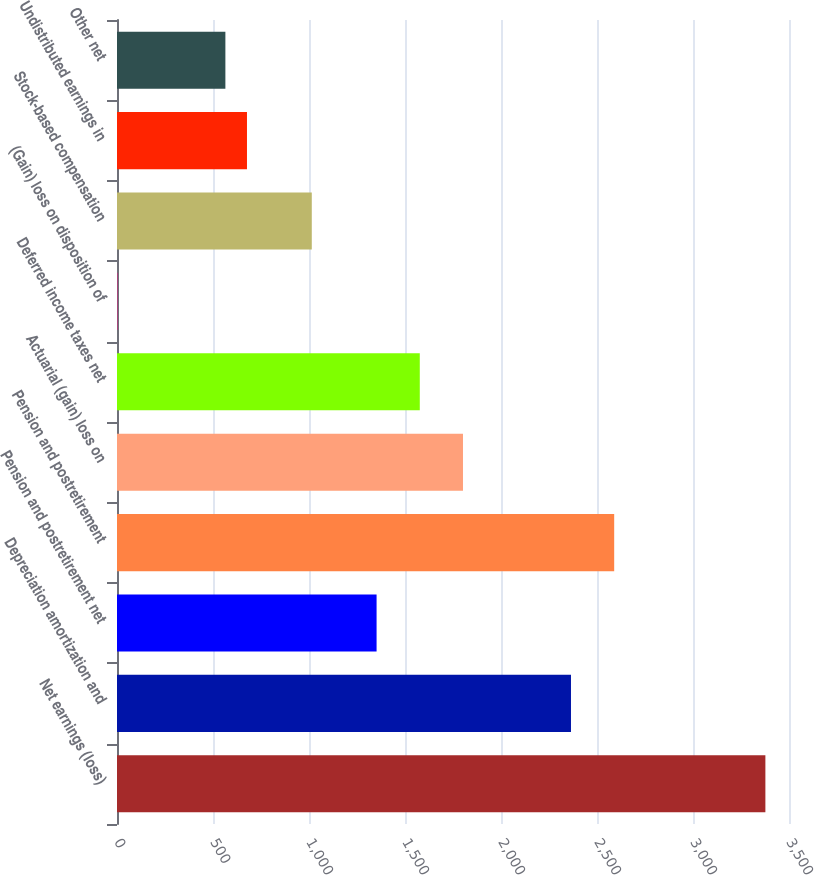Convert chart. <chart><loc_0><loc_0><loc_500><loc_500><bar_chart><fcel>Net earnings (loss)<fcel>Depreciation amortization and<fcel>Pension and postretirement net<fcel>Pension and postretirement<fcel>Actuarial (gain) loss on<fcel>Deferred income taxes net<fcel>(Gain) loss on disposition of<fcel>Stock-based compensation<fcel>Undistributed earnings in<fcel>Other net<nl><fcel>3377<fcel>2364.5<fcel>1352<fcel>2589.5<fcel>1802<fcel>1577<fcel>2<fcel>1014.5<fcel>677<fcel>564.5<nl></chart> 